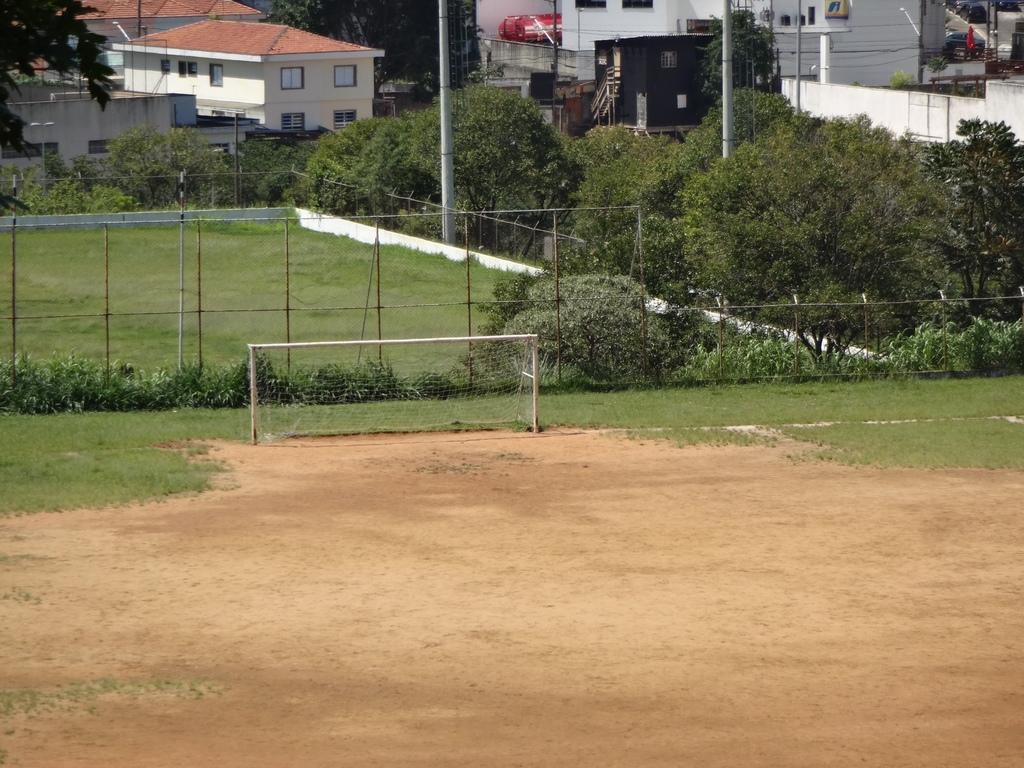Describe this image in one or two sentences. As we can see in the image there is fence, plants, trees, grass and buildings. 